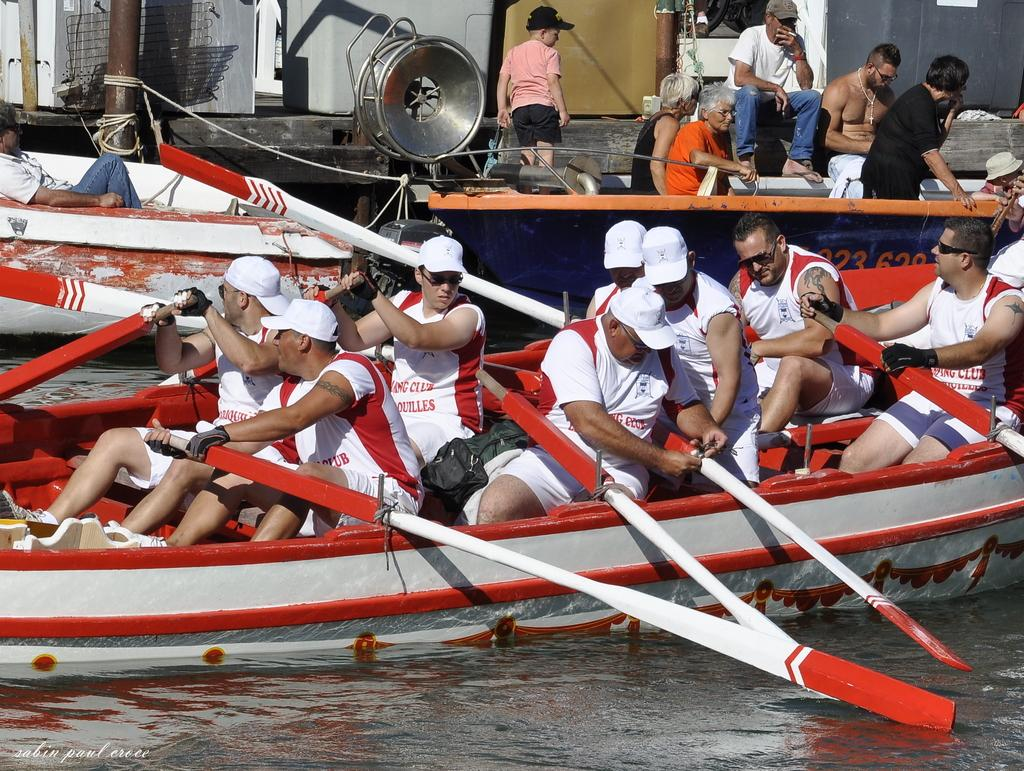What are the people in the image doing? There are people sitting on a boat in the image. What else can be seen in the background of the image? There are boats and people in the background of the image. What object is present in the image that might be used for support or guidance? There is a pole in the image. What is the primary substance visible at the bottom of the image? Water is visible at the bottom of the image. What type of bell can be heard ringing in the image? There is no bell present in the image, and therefore no sound can be heard. 